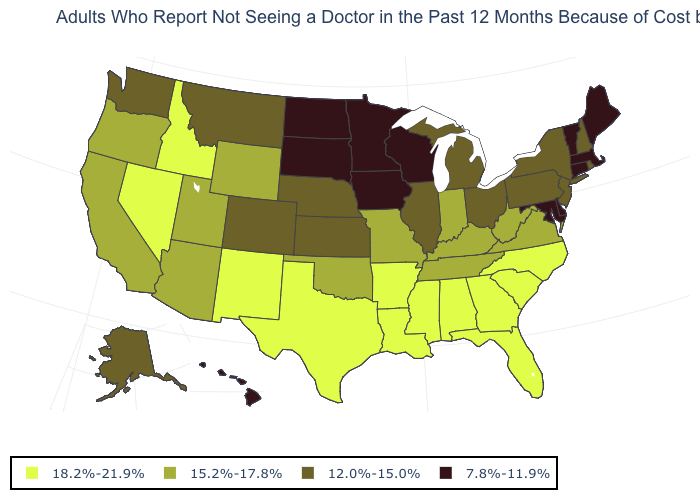Name the states that have a value in the range 7.8%-11.9%?
Concise answer only. Connecticut, Delaware, Hawaii, Iowa, Maine, Maryland, Massachusetts, Minnesota, North Dakota, South Dakota, Vermont, Wisconsin. What is the value of Oklahoma?
Write a very short answer. 15.2%-17.8%. What is the value of Maryland?
Be succinct. 7.8%-11.9%. Does Indiana have the same value as Wyoming?
Give a very brief answer. Yes. Name the states that have a value in the range 7.8%-11.9%?
Short answer required. Connecticut, Delaware, Hawaii, Iowa, Maine, Maryland, Massachusetts, Minnesota, North Dakota, South Dakota, Vermont, Wisconsin. Does South Dakota have the same value as Minnesota?
Give a very brief answer. Yes. What is the value of Maryland?
Quick response, please. 7.8%-11.9%. What is the lowest value in the USA?
Keep it brief. 7.8%-11.9%. What is the value of Pennsylvania?
Short answer required. 12.0%-15.0%. Does Kansas have the lowest value in the USA?
Short answer required. No. Does Nevada have a higher value than Mississippi?
Answer briefly. No. Does Ohio have a higher value than North Dakota?
Concise answer only. Yes. Does Mississippi have the same value as South Carolina?
Short answer required. Yes. Does Florida have the highest value in the USA?
Concise answer only. Yes. Name the states that have a value in the range 15.2%-17.8%?
Write a very short answer. Arizona, California, Indiana, Kentucky, Missouri, Oklahoma, Oregon, Tennessee, Utah, Virginia, West Virginia, Wyoming. 